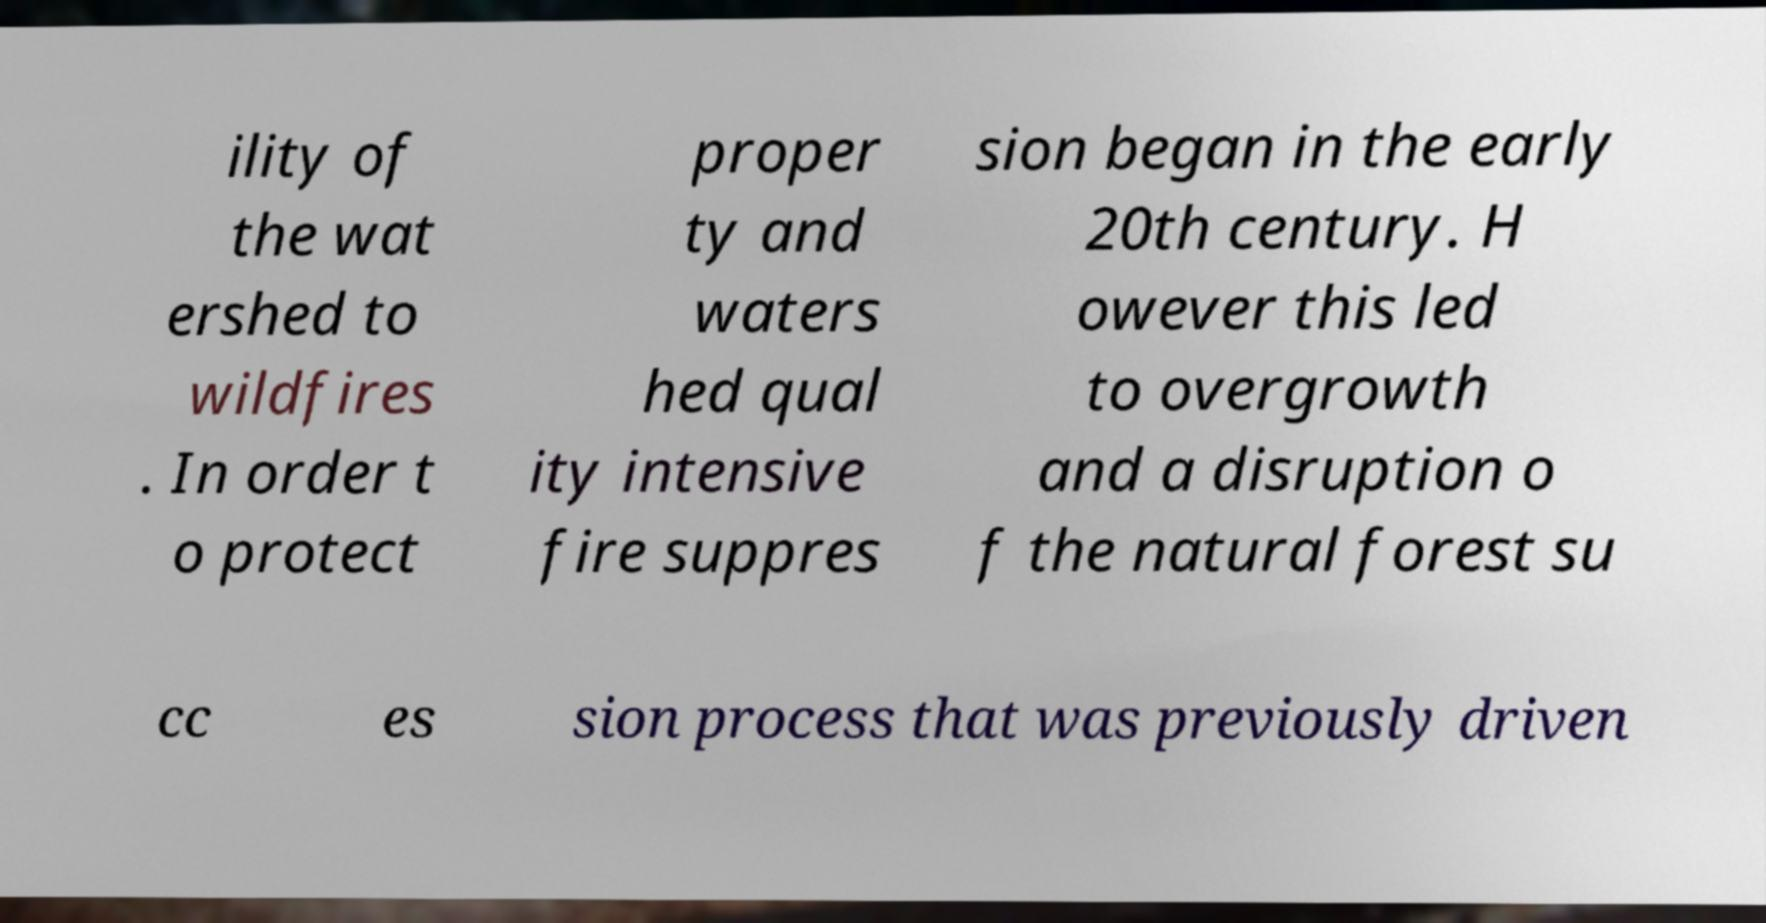Please identify and transcribe the text found in this image. ility of the wat ershed to wildfires . In order t o protect proper ty and waters hed qual ity intensive fire suppres sion began in the early 20th century. H owever this led to overgrowth and a disruption o f the natural forest su cc es sion process that was previously driven 